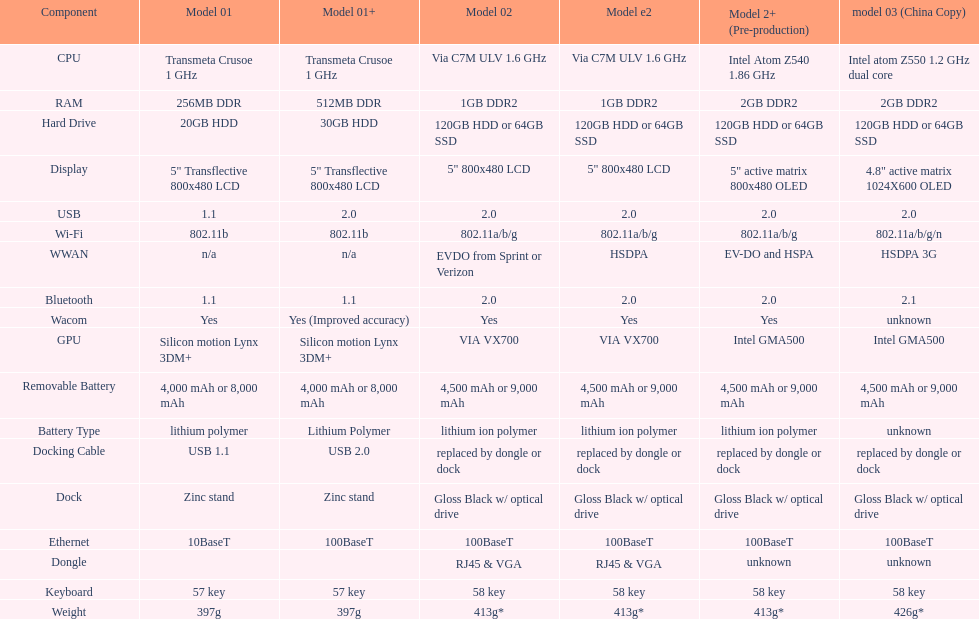The model 2 and the model 2e have what type of cpu? Via C7M ULV 1.6 GHz. 